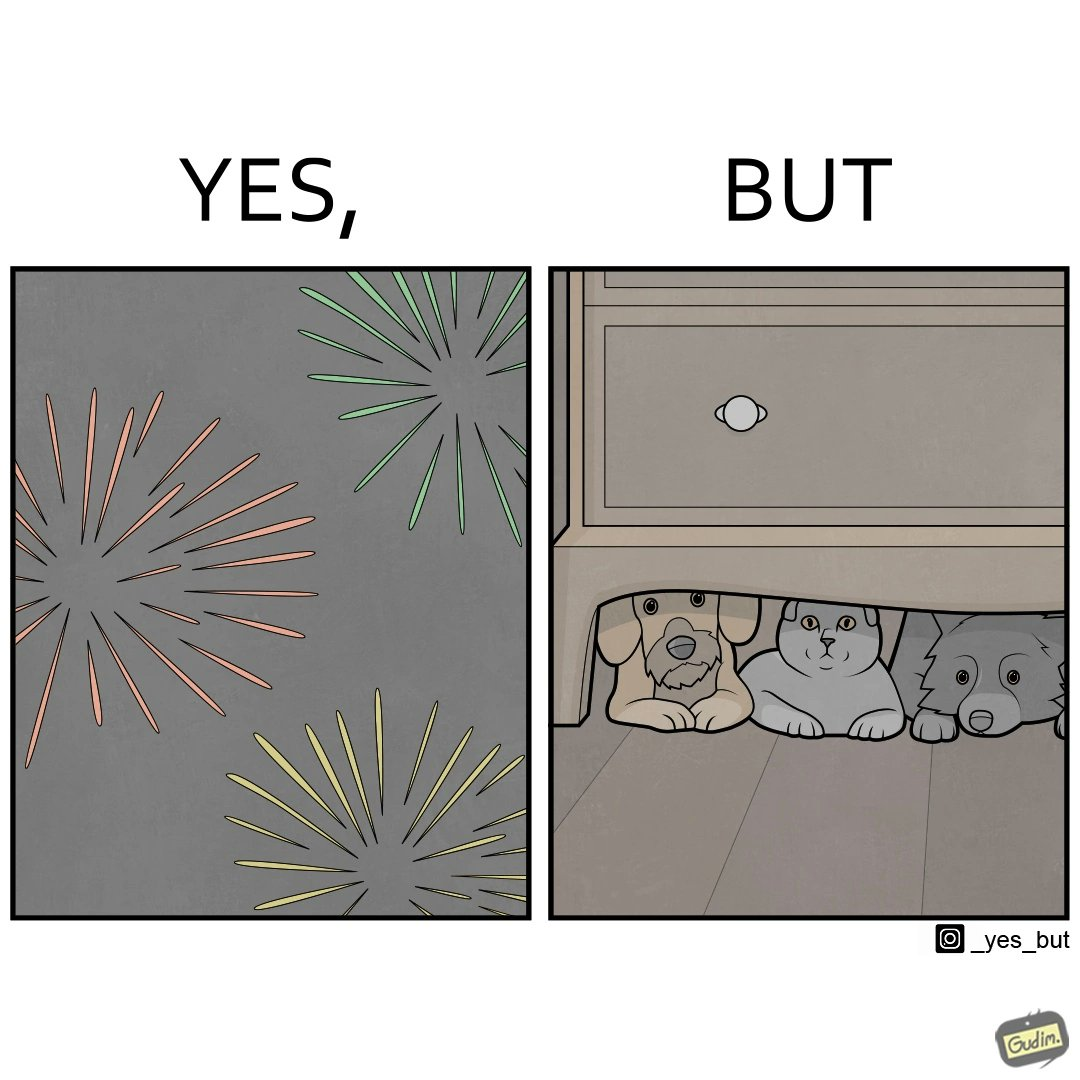Is this image satirical or non-satirical? Yes, this image is satirical. 